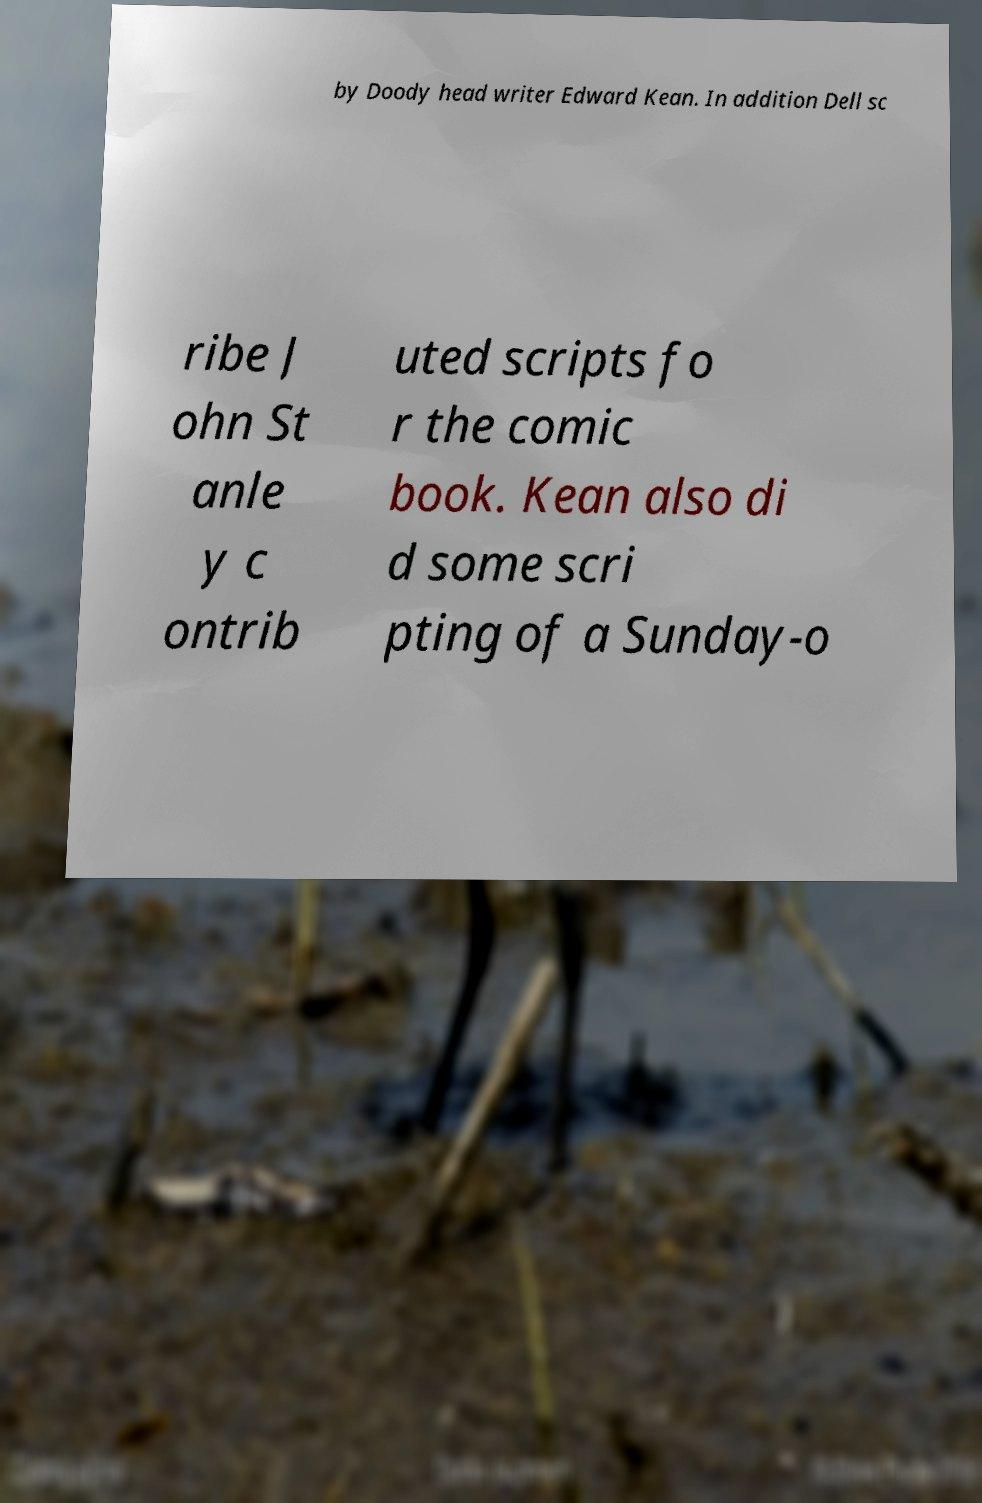Please read and relay the text visible in this image. What does it say? by Doody head writer Edward Kean. In addition Dell sc ribe J ohn St anle y c ontrib uted scripts fo r the comic book. Kean also di d some scri pting of a Sunday-o 